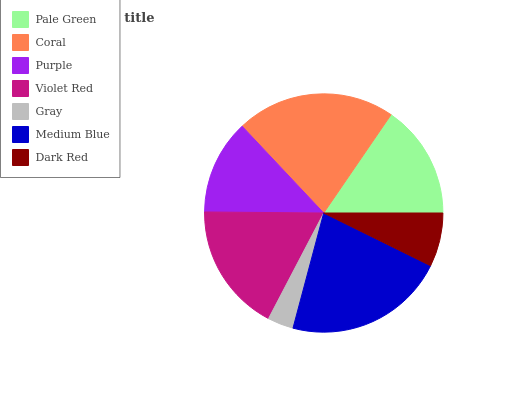Is Gray the minimum?
Answer yes or no. Yes. Is Medium Blue the maximum?
Answer yes or no. Yes. Is Coral the minimum?
Answer yes or no. No. Is Coral the maximum?
Answer yes or no. No. Is Coral greater than Pale Green?
Answer yes or no. Yes. Is Pale Green less than Coral?
Answer yes or no. Yes. Is Pale Green greater than Coral?
Answer yes or no. No. Is Coral less than Pale Green?
Answer yes or no. No. Is Pale Green the high median?
Answer yes or no. Yes. Is Pale Green the low median?
Answer yes or no. Yes. Is Coral the high median?
Answer yes or no. No. Is Medium Blue the low median?
Answer yes or no. No. 